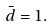<formula> <loc_0><loc_0><loc_500><loc_500>\bar { d } = 1 .</formula> 